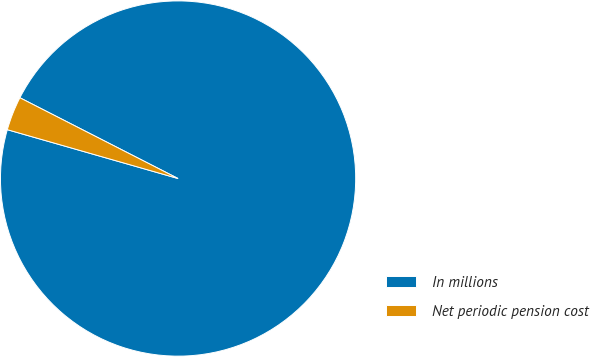Convert chart to OTSL. <chart><loc_0><loc_0><loc_500><loc_500><pie_chart><fcel>In millions<fcel>Net periodic pension cost<nl><fcel>96.92%<fcel>3.08%<nl></chart> 